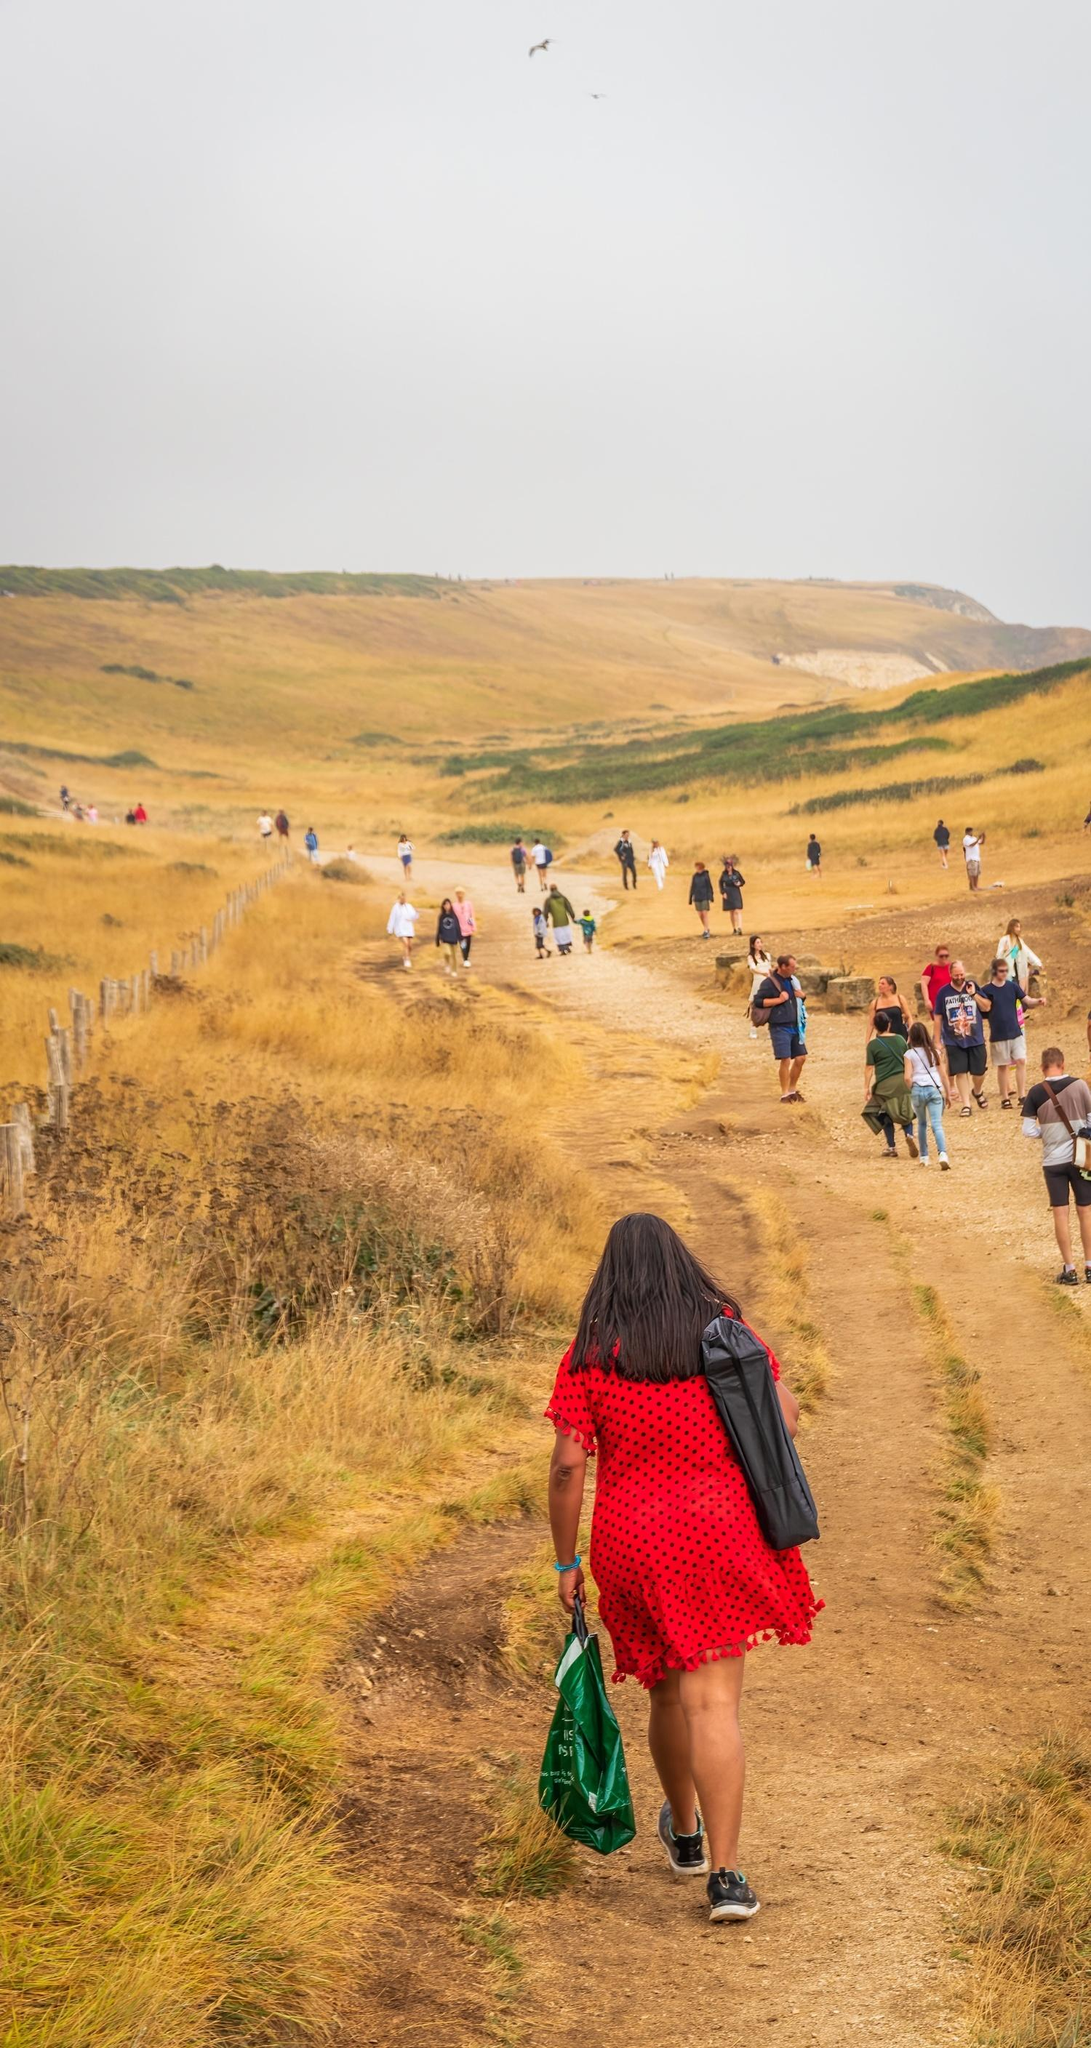Imagine this image as part of a magical realm. What kind of adventures could the people be embarking on? In a magical realm, these travelers might be embarking on an epic quest, each carrying enchanted artifacts that would guide them to a hidden portal, secretly nestled within the hills, which led to an ancient, forgotten civilization. Along their journey, the path would reveal magical flora that whispered secrets, and mystical creatures would watch from the shadows, offering cryptic guidance or challenging their resolve. Their destination could be a crystal castle floating above a shimmering lake that only appears under a full moon, where they must solve riddles and overcome trials to unlock an ancient power that could save their realm. Their adventure would be filled with spells, mythical beasts, and the unbreakable bond of fellowship forged in the crucible of both wonder and peril. 